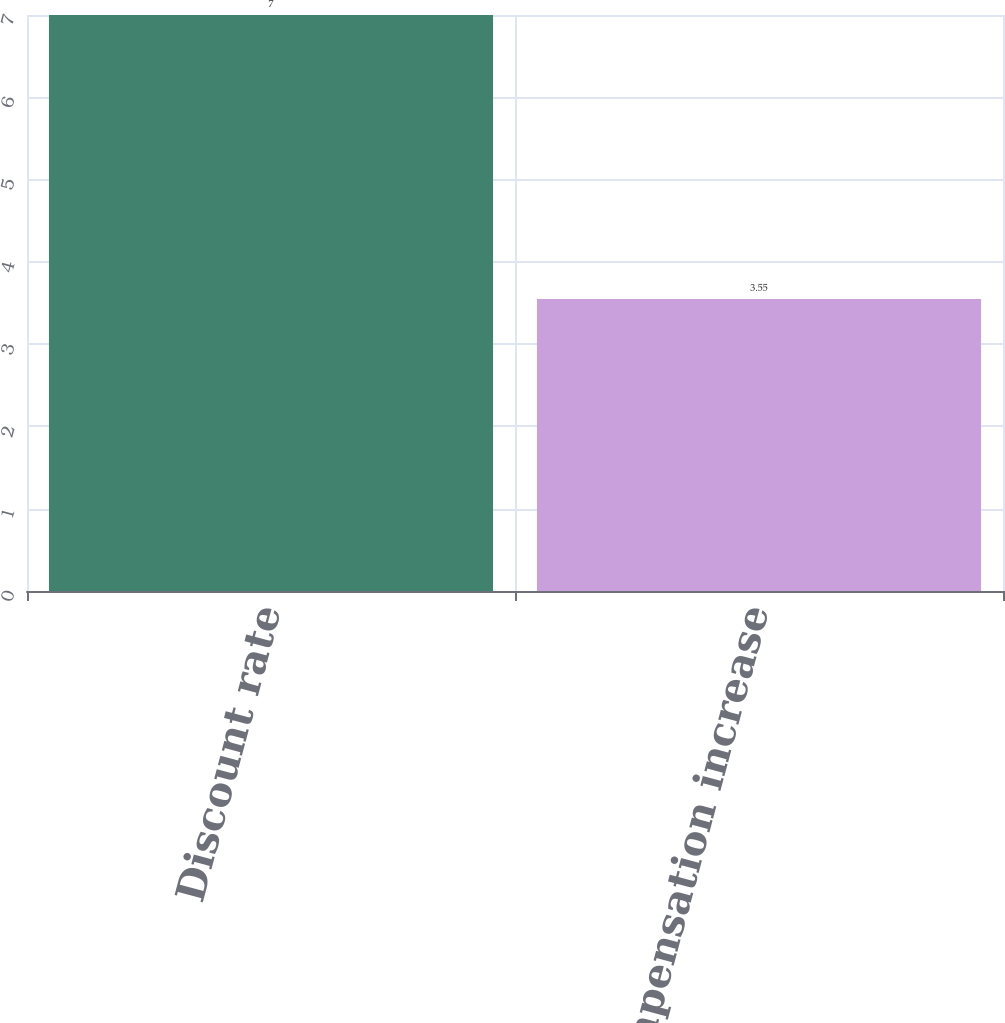Convert chart to OTSL. <chart><loc_0><loc_0><loc_500><loc_500><bar_chart><fcel>Discount rate<fcel>Rate of compensation increase<nl><fcel>7<fcel>3.55<nl></chart> 